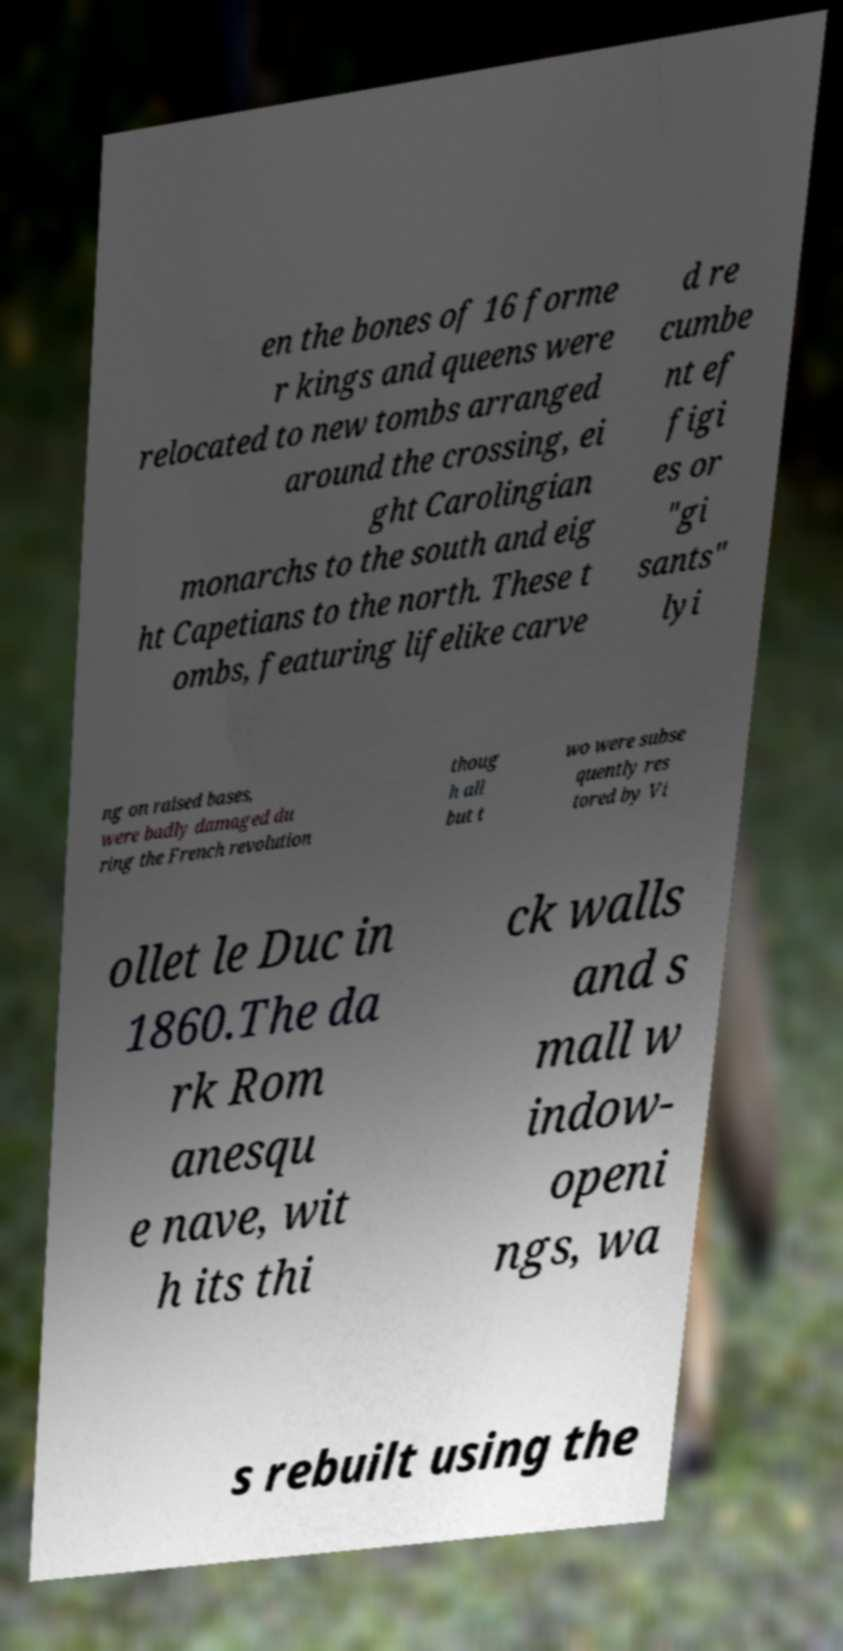Can you accurately transcribe the text from the provided image for me? en the bones of 16 forme r kings and queens were relocated to new tombs arranged around the crossing, ei ght Carolingian monarchs to the south and eig ht Capetians to the north. These t ombs, featuring lifelike carve d re cumbe nt ef figi es or "gi sants" lyi ng on raised bases, were badly damaged du ring the French revolution thoug h all but t wo were subse quently res tored by Vi ollet le Duc in 1860.The da rk Rom anesqu e nave, wit h its thi ck walls and s mall w indow- openi ngs, wa s rebuilt using the 